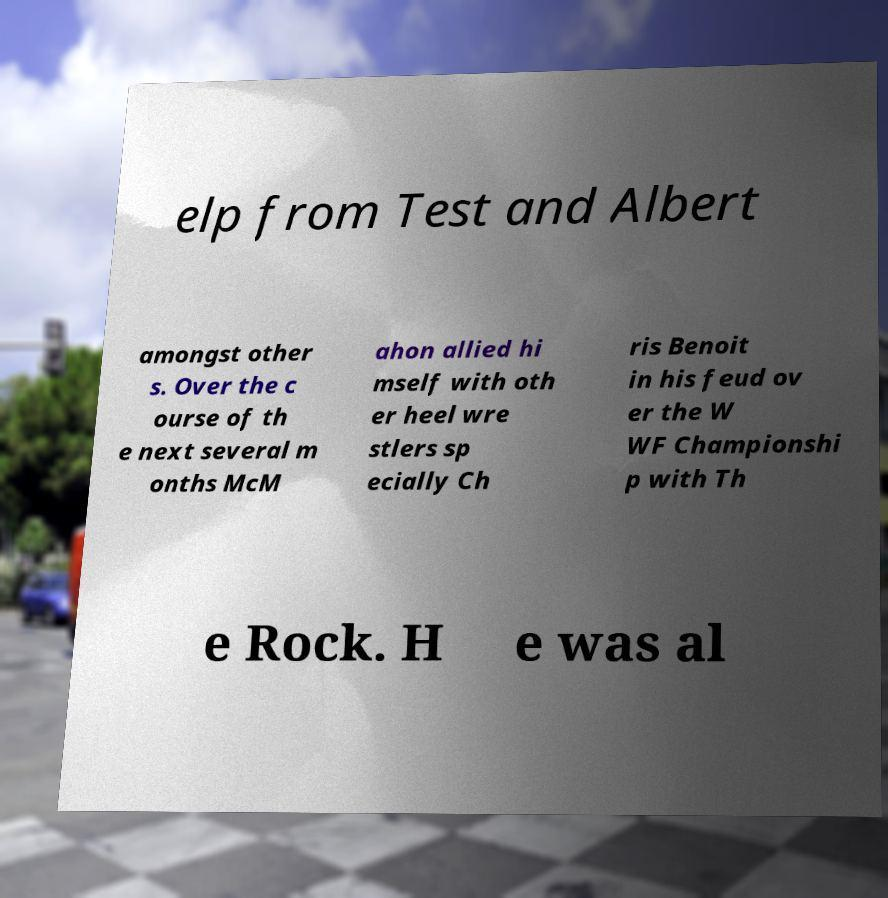Can you accurately transcribe the text from the provided image for me? elp from Test and Albert amongst other s. Over the c ourse of th e next several m onths McM ahon allied hi mself with oth er heel wre stlers sp ecially Ch ris Benoit in his feud ov er the W WF Championshi p with Th e Rock. H e was al 